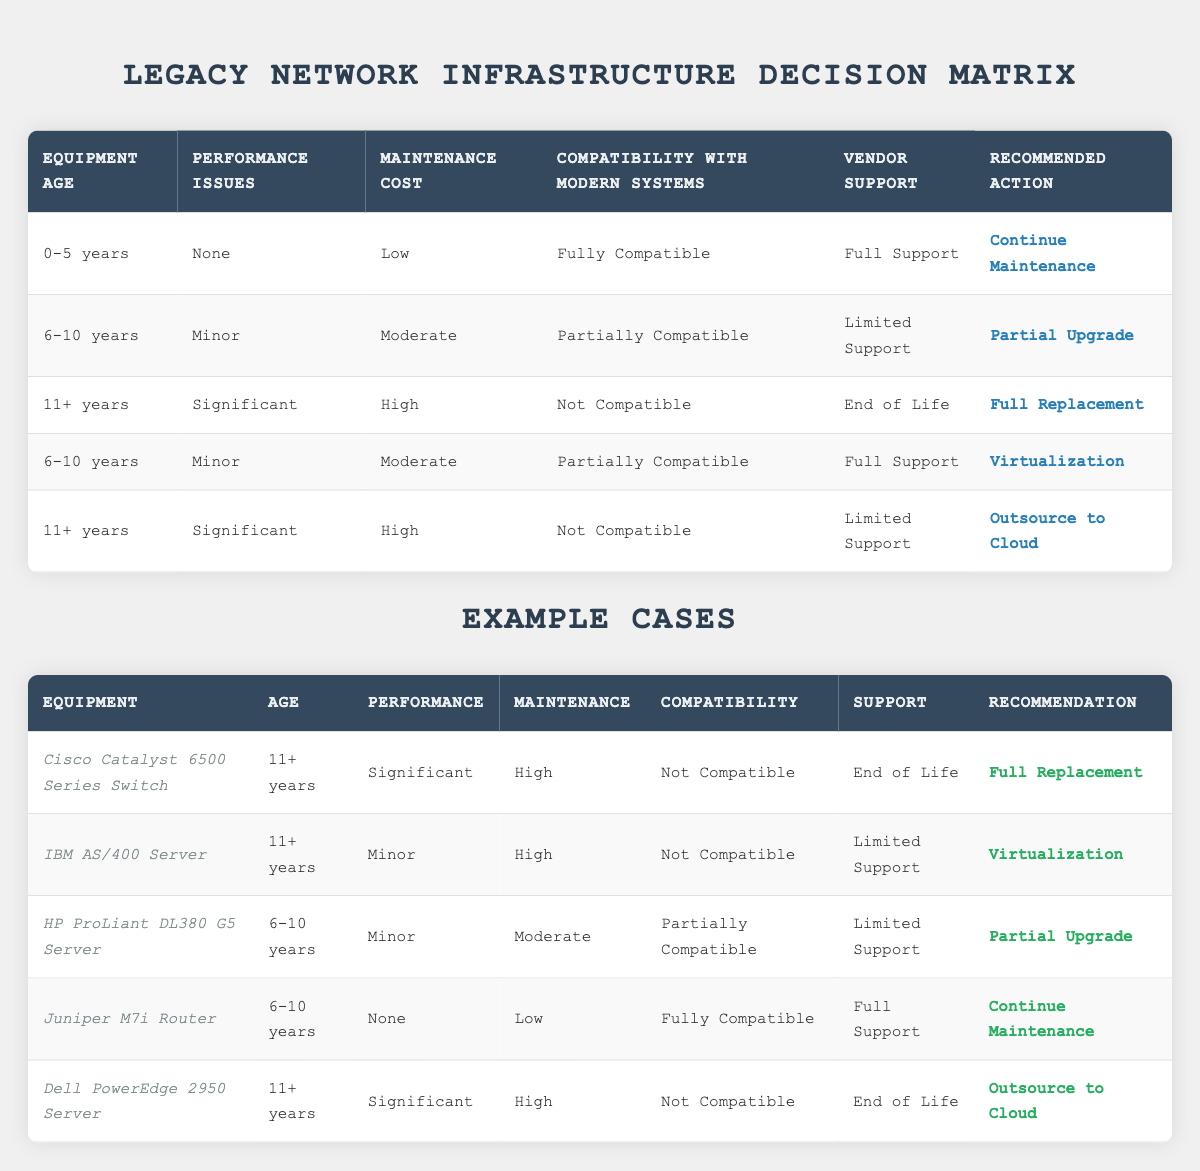What action should be taken for equipment aged 0-5 years with no performance issues, low maintenance cost, full compatibility, and full vendor support? According to the table, if the equipment is aged 0-5 years, has no performance issues, low maintenance cost, full compatibility with modern systems, and receives full vendor support, the recommended action is to "Continue Maintenance" as stated in the corresponding rule in the table.
Answer: Continue Maintenance What is the recommendation for a device that is 11+ years old with significant performance issues and high maintenance costs, yet has limited support? For equipment that is 11+ years old experiencing significant performance issues and high maintenance costs while having limited support, the recommendation according to the table is to "Outsource to Cloud." This follows the specific conditions outlined in the rules.
Answer: Outsource to Cloud How many total examples are there in the table? The table lists a total of 5 examples: Cisco Catalyst 6500 Series Switch, IBM AS/400 Server, HP ProLiant DL380 G5 Server, Juniper M7i Router, and Dell PowerEdge 2950 Server. Therefore, there are 5 examples in total.
Answer: 5 Is the HP ProLiant DL380 G5 Server compatible with modern systems? The table shows that the HP ProLiant DL380 G5 Server is classified as "Partially Compatible" with modern systems. Therefore, the answer to the compatibility question is "No."
Answer: No What action would be recommended for a 6-10 years old device with minor performance issues, moderate maintenance costs, and full support? To find the recommendation for this scenario, we check the rule that fits these conditions: for a 6-10 years old device with minor performance issues, moderate maintenance costs, and full support, the table indicates that the recommended action is "Virtualization."
Answer: Virtualization What is the sum of the actions recommended for devices that are 11+ years old? From the examples, devices aged 11+ years are: Cisco Catalyst (Full Replacement), IBM AS/400 Server (Virtualization), and Dell PowerEdge (Outsource to Cloud). The sum of these recommendations involves filtering the actions associated with age. The result is 3 different actions taken for 2 distinct recommendations (Full Replacement and Outsource to Cloud). Hence, the unique number of actions is 2.
Answer: 2 Does the Juniper M7i Router require an upgrade? Based on the table, the Juniper M7i Router shows "None" for performance issues and it is within the 6-10 years age bracket with "Fully Compatible" and "Full Support." Therefore, no upgrade is necessary, confirming that it should just "Continue Maintenance."
Answer: No What are the conditions under which a partial upgrade is recommended? A partial upgrade is recommended if the equipment is aged between 6-10 years, has minor performance issues, moderate maintenance costs, is partially compatible with modern systems, and has limited support based on the specified rule in the table.
Answer: 6-10 years, Minor Issues, Moderate Cost, Partially Compatible, Limited Support If a device is 11+ years old and is fully compatible but has significant performance issues, what action is recommended? According to the rules in the table, even if the device is 11+ years old, if it is fully compatible but has significant performance issues, it would still fall under the rule for full replacement, given the compatibility does not negate the recommendation on age and issues. The result indicates that it still suggests a "Full Replacement."
Answer: Full Replacement 